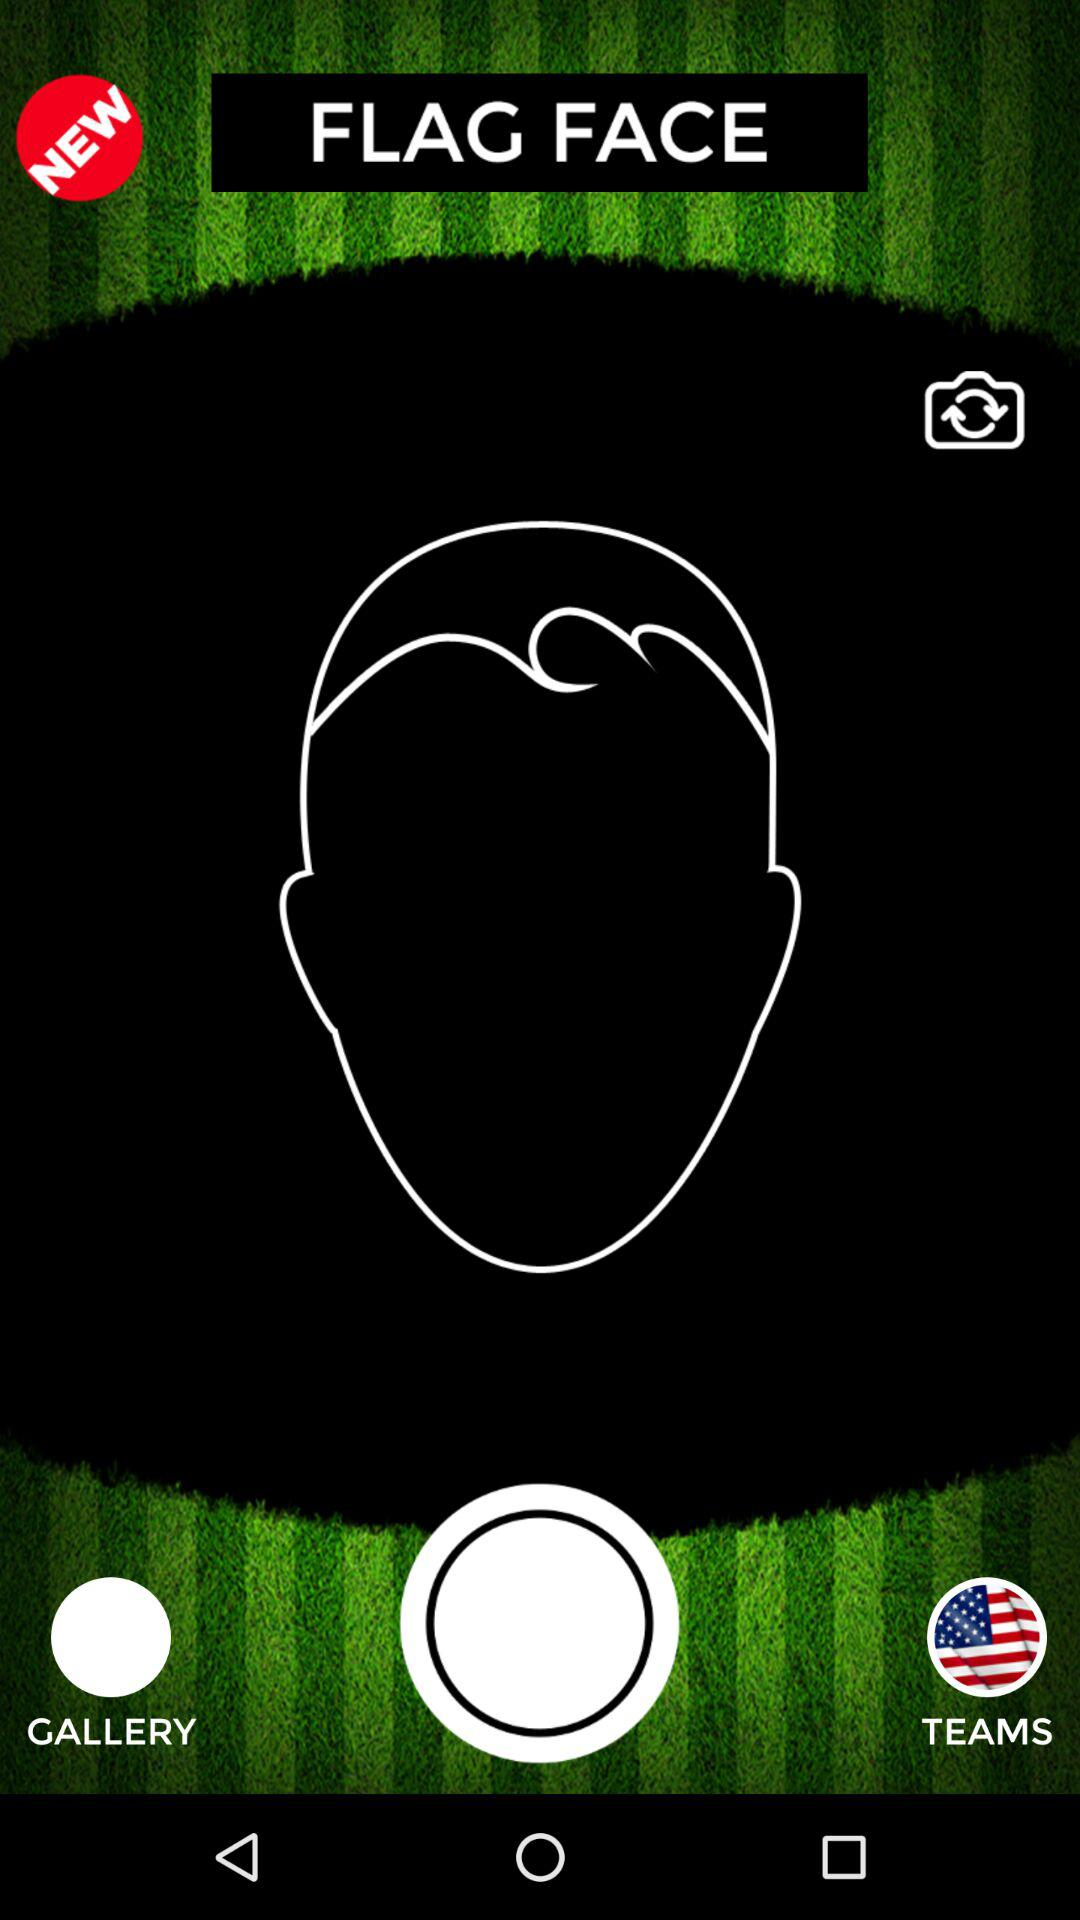What is the application name? The application name is "FLAG FACE". 